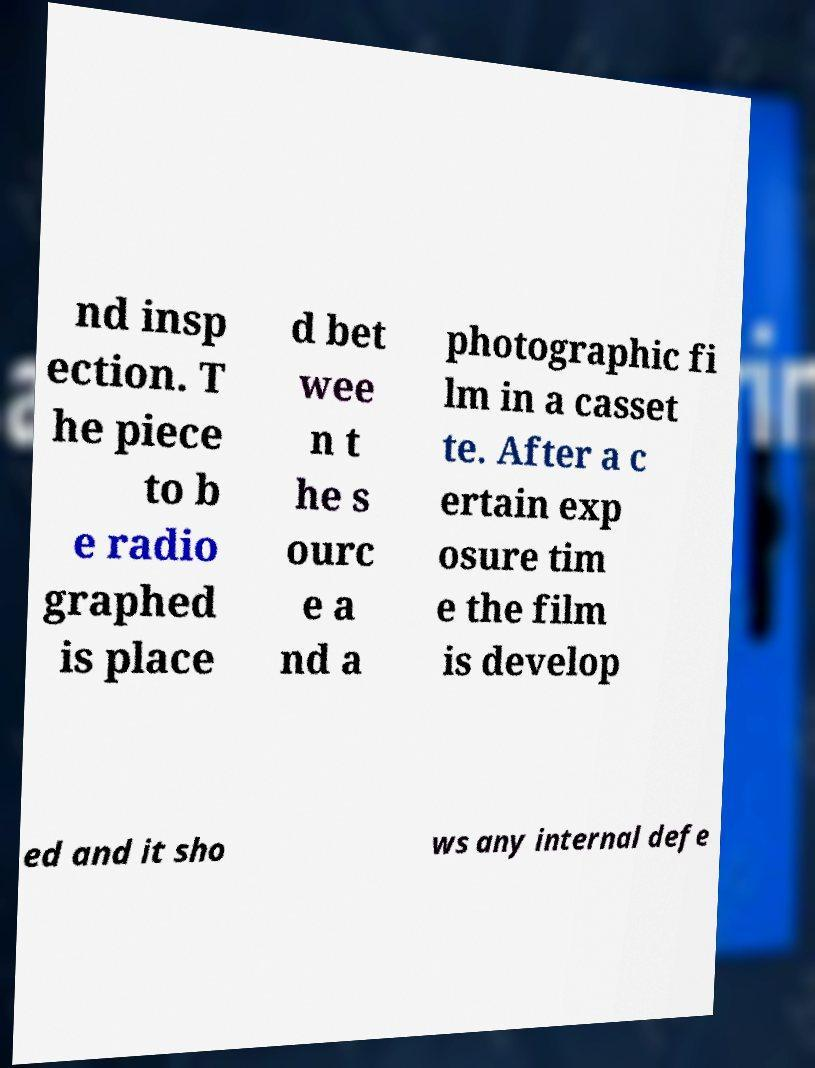I need the written content from this picture converted into text. Can you do that? nd insp ection. T he piece to b e radio graphed is place d bet wee n t he s ourc e a nd a photographic fi lm in a casset te. After a c ertain exp osure tim e the film is develop ed and it sho ws any internal defe 